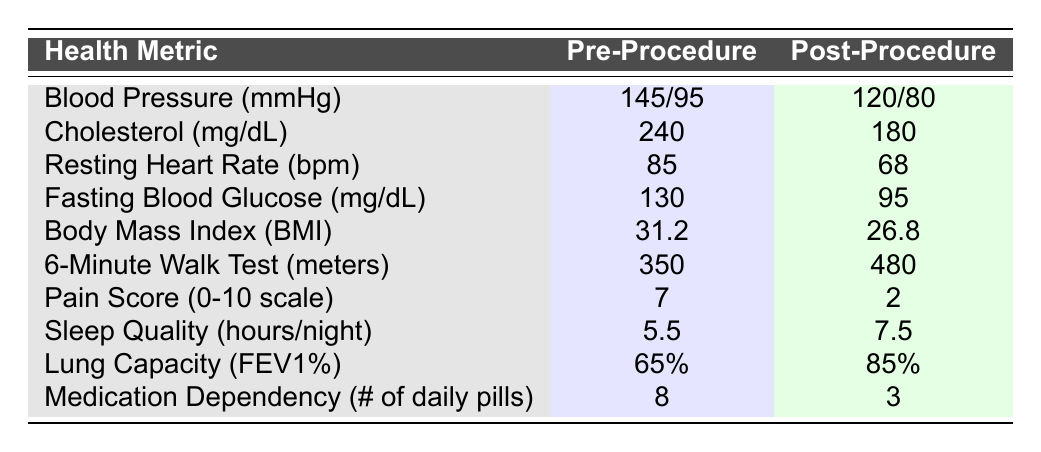What was the blood pressure before the procedure? The table shows the "Pre-Procedure" value for Blood Pressure as 145/95 mmHg.
Answer: 145/95 mmHg What is the change in cholesterol levels after the procedure? Before the procedure, cholesterol was 240 mg/dL and after it was 180 mg/dL. The change is 240 - 180 = 60 mg/dL.
Answer: 60 mg/dL Is the resting heart rate lower after the procedure? The "Post-Procedure" resting heart rate is 68 bpm, and the "Pre-Procedure" is 85 bpm. Since 68 < 85, the heart rate is lower.
Answer: Yes What is the total decrease in daily medication dependency? The "Pre-Procedure" medication dependency was 8 pills, and "Post-Procedure" it is 3 pills. The decrease is 8 - 3 = 5 pills.
Answer: 5 pills What improvement was observed in the 6-minute walk test? The Pre-Procedure value was 350 meters, and Post-Procedure it was 480 meters. The improvement is 480 - 350 = 130 meters.
Answer: 130 meters Did the pain score improve significantly after the procedure? The "Pre-Procedure" pain score was 7 and the "Post-Procedure" score is 2. Since 2 is lower than 7, this indicates significant improvement.
Answer: Yes What percentage increase in lung capacity was recorded? The Pre-Procedure lung capacity was 65% and Post-Procedure it was 85%. The percentage increase is ((85 - 65) / 65) * 100 = 30.77%.
Answer: 30.77% What was the average improvement across all health metrics? First, determine improvements: Blood Pressure: 25, Cholesterol: 60, Resting Heart Rate: 17, Fasting Blood Glucose: 35, BMI: 4.4, 6-Minute Walk: 130, Pain Score: 5, Sleep Quality: 2, Lung Capacity: 20, Medication Dependency: 5. The sum of improvements is 25 + 60 + 17 + 35 + 4.4 + 130 + 5 + 2 + 20 + 5 = 329. There are 10 metrics, so the average improvement is 329 / 10 = 32.9.
Answer: 32.9 How did sleep quality change after the procedure? Sleep quality improved from 5.5 hours/night (Pre-Procedure) to 7.5 hours/night (Post-Procedure), which is an improvement of 7.5 - 5.5 = 2 hours.
Answer: 2 hours Was there a significant reduction in fasting blood glucose levels? The "Pre-Procedure" fasting blood glucose level was 130 mg/dL and "Post-Procedure" it was 95 mg/dL. Since 95 < 130, there is a significant reduction.
Answer: Yes 